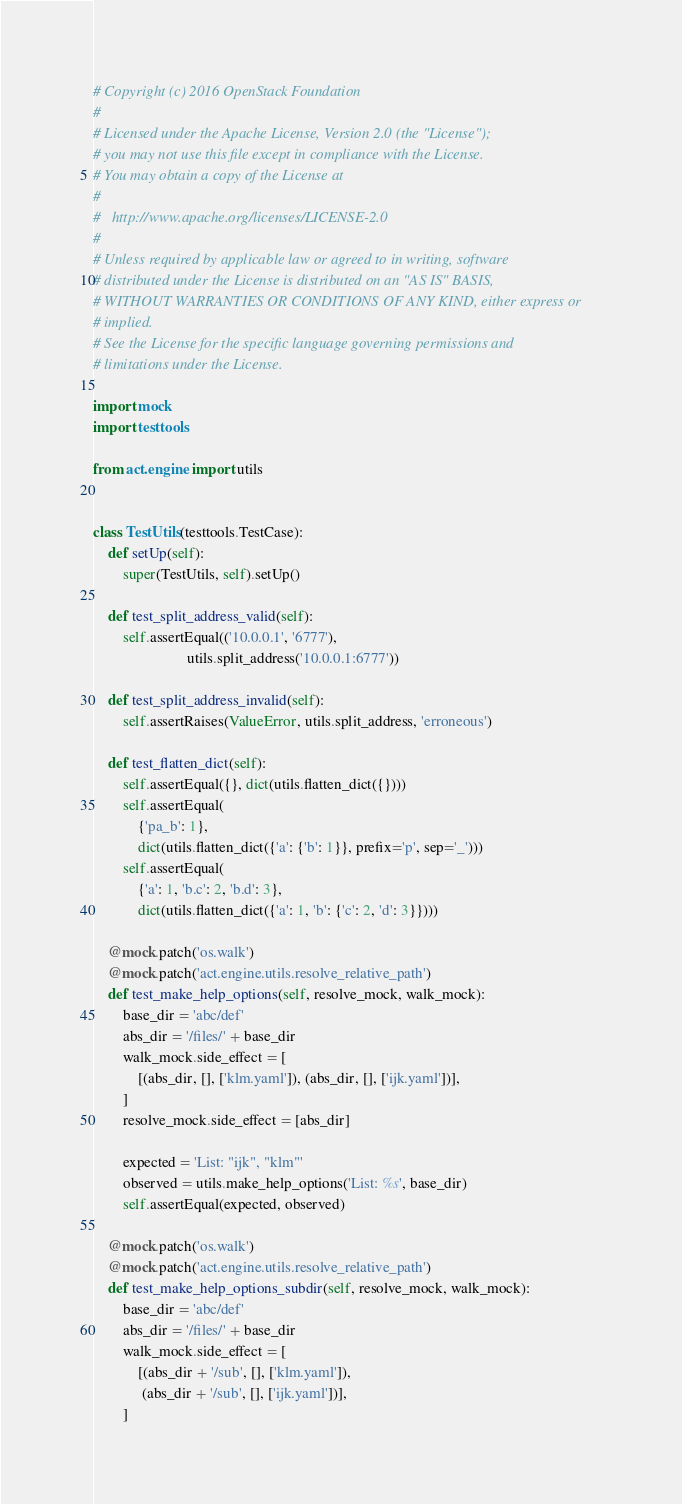Convert code to text. <code><loc_0><loc_0><loc_500><loc_500><_Python_># Copyright (c) 2016 OpenStack Foundation
#
# Licensed under the Apache License, Version 2.0 (the "License");
# you may not use this file except in compliance with the License.
# You may obtain a copy of the License at
#
#   http://www.apache.org/licenses/LICENSE-2.0
#
# Unless required by applicable law or agreed to in writing, software
# distributed under the License is distributed on an "AS IS" BASIS,
# WITHOUT WARRANTIES OR CONDITIONS OF ANY KIND, either express or
# implied.
# See the License for the specific language governing permissions and
# limitations under the License.

import mock
import testtools

from act.engine import utils


class TestUtils(testtools.TestCase):
    def setUp(self):
        super(TestUtils, self).setUp()

    def test_split_address_valid(self):
        self.assertEqual(('10.0.0.1', '6777'),
                         utils.split_address('10.0.0.1:6777'))

    def test_split_address_invalid(self):
        self.assertRaises(ValueError, utils.split_address, 'erroneous')

    def test_flatten_dict(self):
        self.assertEqual({}, dict(utils.flatten_dict({})))
        self.assertEqual(
            {'pa_b': 1},
            dict(utils.flatten_dict({'a': {'b': 1}}, prefix='p', sep='_')))
        self.assertEqual(
            {'a': 1, 'b.c': 2, 'b.d': 3},
            dict(utils.flatten_dict({'a': 1, 'b': {'c': 2, 'd': 3}})))

    @mock.patch('os.walk')
    @mock.patch('act.engine.utils.resolve_relative_path')
    def test_make_help_options(self, resolve_mock, walk_mock):
        base_dir = 'abc/def'
        abs_dir = '/files/' + base_dir
        walk_mock.side_effect = [
            [(abs_dir, [], ['klm.yaml']), (abs_dir, [], ['ijk.yaml'])],
        ]
        resolve_mock.side_effect = [abs_dir]

        expected = 'List: "ijk", "klm"'
        observed = utils.make_help_options('List: %s', base_dir)
        self.assertEqual(expected, observed)

    @mock.patch('os.walk')
    @mock.patch('act.engine.utils.resolve_relative_path')
    def test_make_help_options_subdir(self, resolve_mock, walk_mock):
        base_dir = 'abc/def'
        abs_dir = '/files/' + base_dir
        walk_mock.side_effect = [
            [(abs_dir + '/sub', [], ['klm.yaml']),
             (abs_dir + '/sub', [], ['ijk.yaml'])],
        ]</code> 